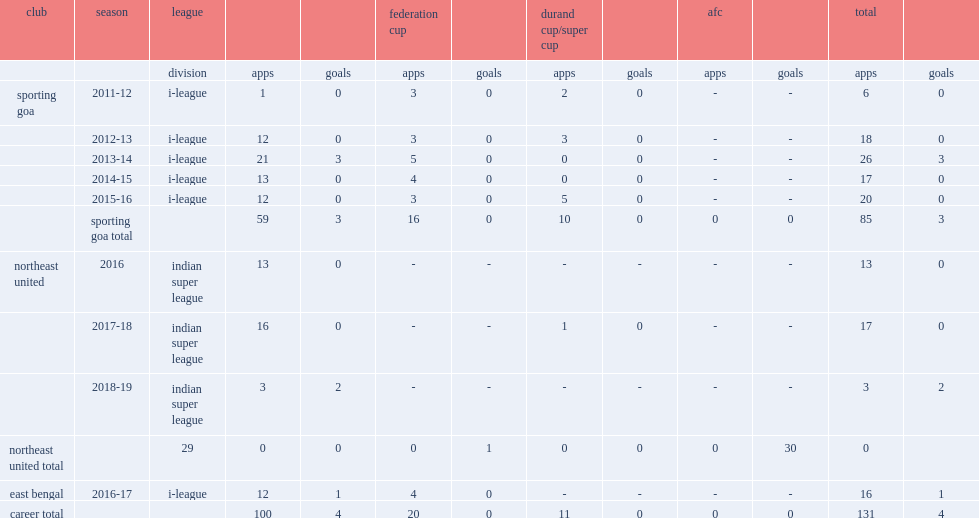In 2016, after spending a season with northeast united in the indian super league. Indian super league. 